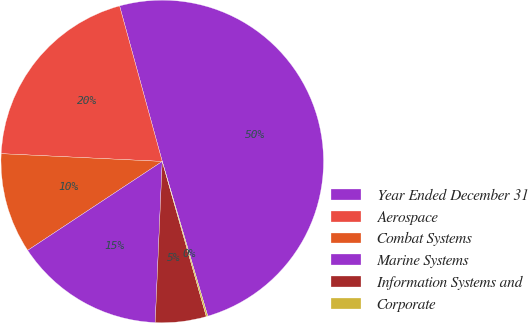<chart> <loc_0><loc_0><loc_500><loc_500><pie_chart><fcel>Year Ended December 31<fcel>Aerospace<fcel>Combat Systems<fcel>Marine Systems<fcel>Information Systems and<fcel>Corporate<nl><fcel>49.7%<fcel>19.97%<fcel>10.06%<fcel>15.01%<fcel>5.1%<fcel>0.15%<nl></chart> 